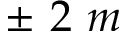<formula> <loc_0><loc_0><loc_500><loc_500>\pm 2 m</formula> 